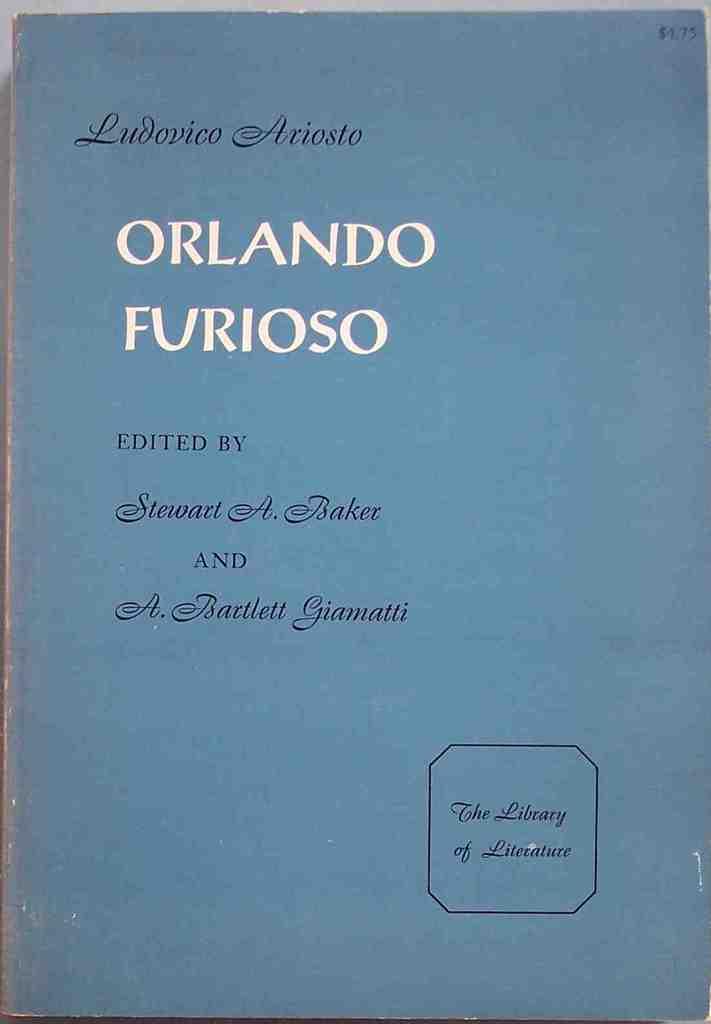Who edited this book?
Ensure brevity in your answer.  Stewart a. baker and a. bartlett giamatti. What is the title of this book?
Offer a terse response. Orlando furioso. 